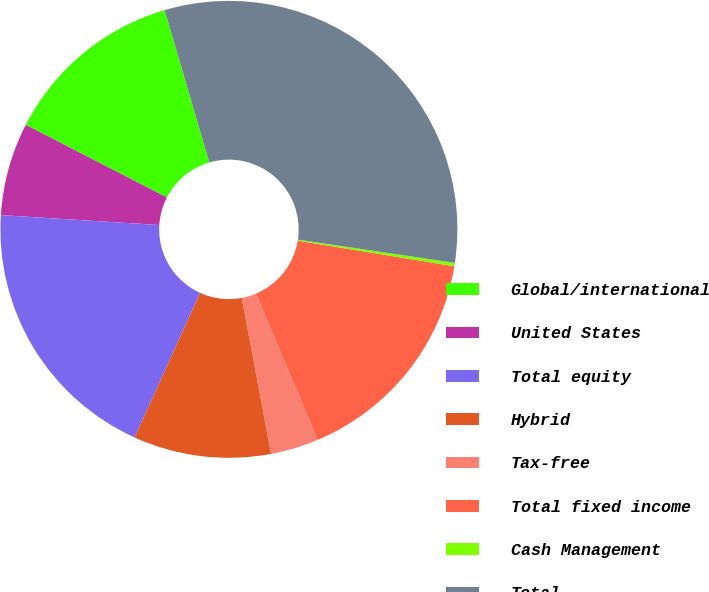<chart> <loc_0><loc_0><loc_500><loc_500><pie_chart><fcel>Global/international<fcel>United States<fcel>Total equity<fcel>Hybrid<fcel>Tax-free<fcel>Total fixed income<fcel>Cash Management<fcel>Total<nl><fcel>12.9%<fcel>6.57%<fcel>19.22%<fcel>9.73%<fcel>3.4%<fcel>16.06%<fcel>0.24%<fcel>31.88%<nl></chart> 